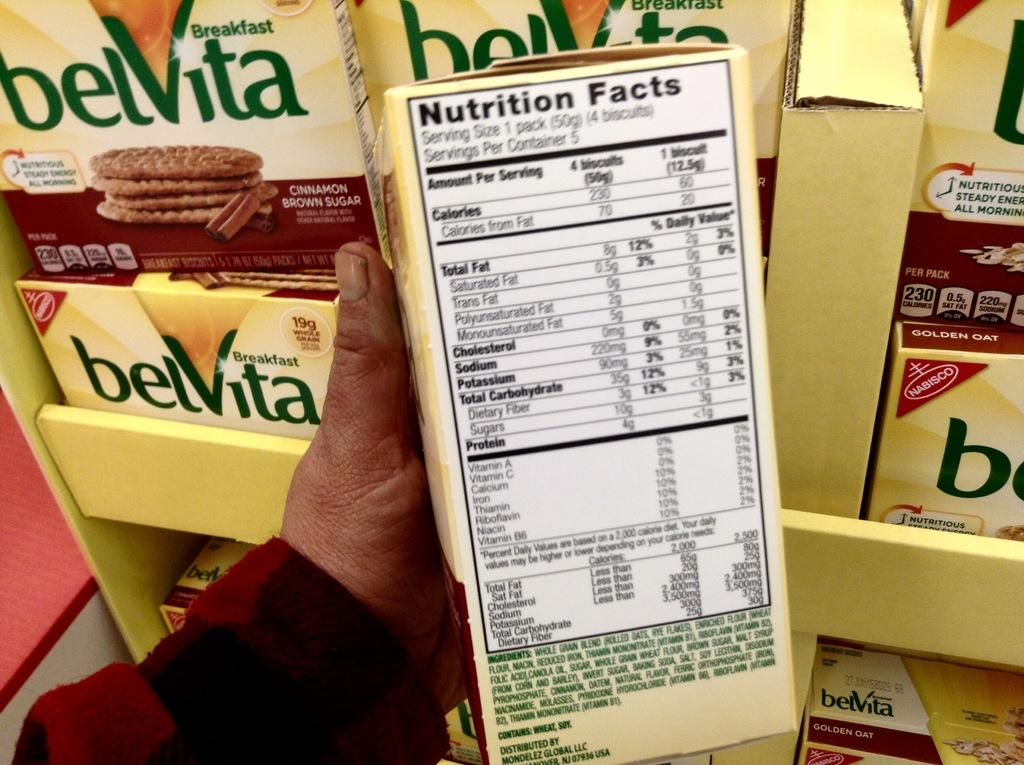<image>
Describe the image concisely. A person is holding a box of golden oat belVita with the nutritional facts displayed. 